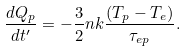Convert formula to latex. <formula><loc_0><loc_0><loc_500><loc_500>\frac { d Q _ { p } } { d t ^ { \prime } } = - \frac { 3 } { 2 } n k \frac { ( T _ { p } - T _ { e } ) } { \tau _ { e p } } .</formula> 